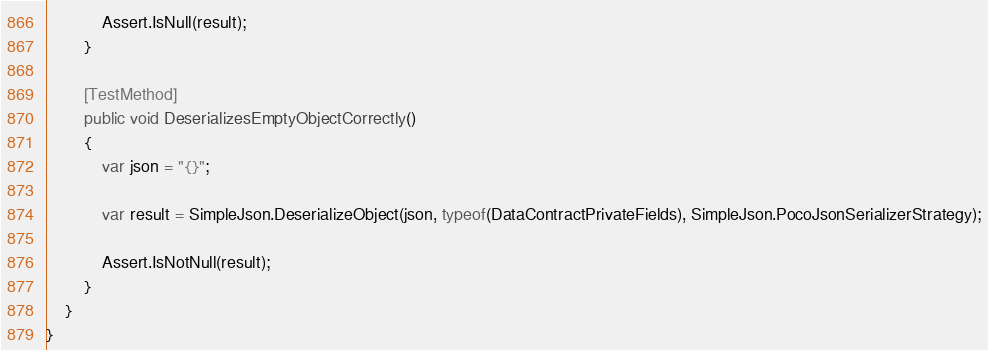Convert code to text. <code><loc_0><loc_0><loc_500><loc_500><_C#_>            Assert.IsNull(result);
        }

        [TestMethod]
        public void DeserializesEmptyObjectCorrectly()
        {
            var json = "{}";

            var result = SimpleJson.DeserializeObject(json, typeof(DataContractPrivateFields), SimpleJson.PocoJsonSerializerStrategy);

            Assert.IsNotNull(result);
        }
    }
}</code> 